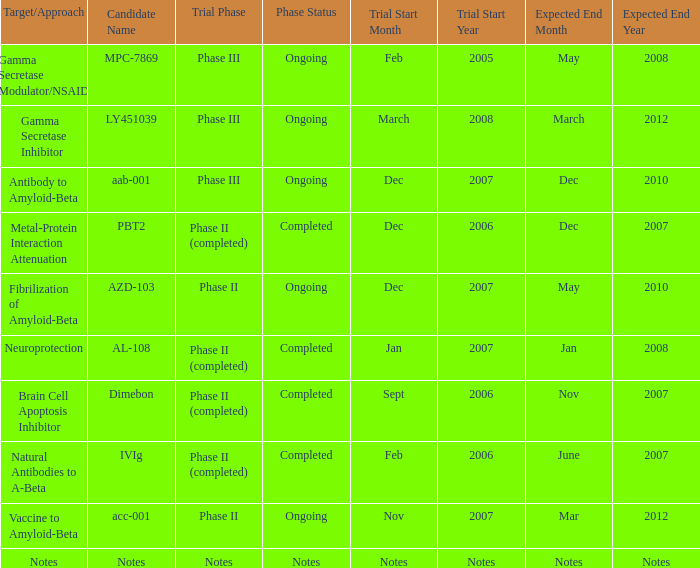For the candidate pbt2, what is the start date of the trial? Dec 2006. 